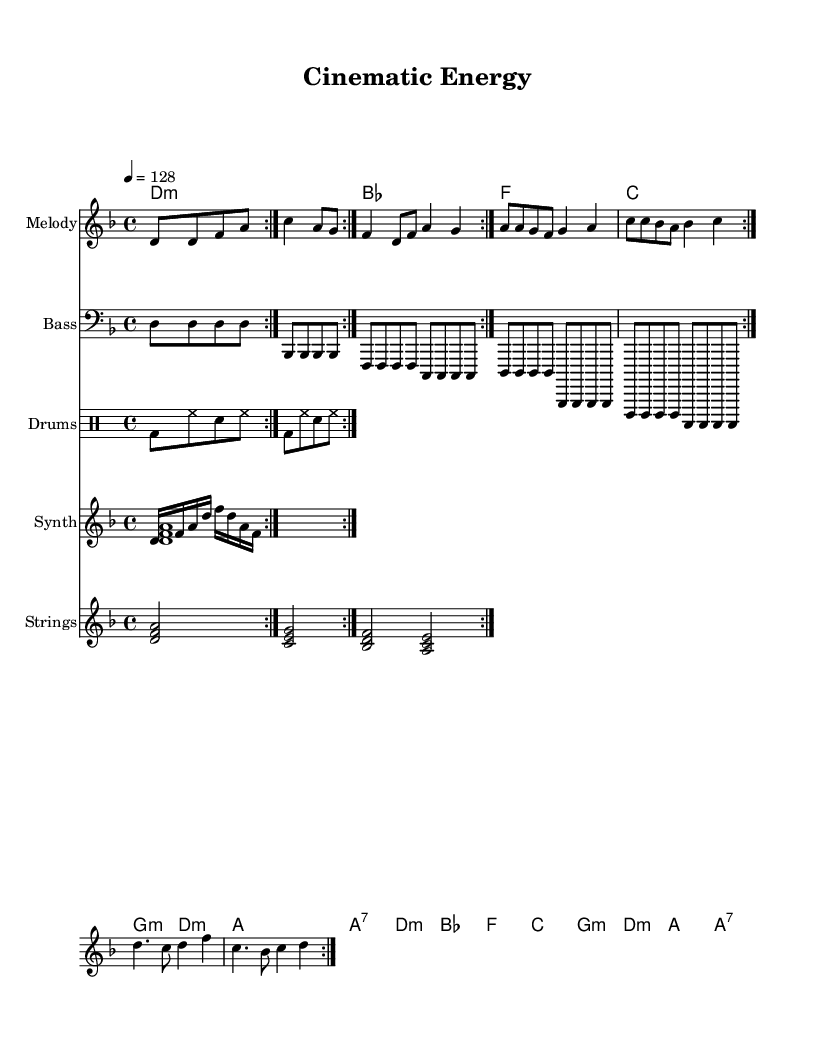What is the key signature of this music? The key signature is indicated at the beginning of the sheet music. Looking at the clef, we can see that it has one flat, positioning it in the key of D minor.
Answer: D minor What is the time signature of this music? The time signature is displayed at the beginning of the score. Here, it is shown as 4/4, indicating four beats per measure.
Answer: 4/4 What is the tempo marking for the piece? The tempo is specified at the beginning with the metronome marking "4 = 128," which indicates that there are 128 beats in a minute, associated with quarter notes.
Answer: 128 How many repetitions are indicated for each section in the melody? In the melody section, the notation "volta 2" indicates that each phrase is to be repeated twice. Thus, each section has two repetitions.
Answer: 2 Which instrument plays the bassline in this score? The bassline is notated on a staff labeled "Bass," which indicates that a bass instrument plays this part specifically.
Answer: Bass What type of drum pattern is utilized in this music? The drum pattern is displayed in a dedicated drum staff, using a standard rock beat format of bass drum (bd), hi-hat (hh), and snare drum (sn), typically common in energetic K-pop tracks.
Answer: Rock beat What is unique about the synthesizer parts in this track? The synthesizer parts include both an arpeggiated figure and a sustained pad, which are characteristic of K-pop music, providing both harmonic texture and rhythmic movement.
Answer: Arpeggiated and sustained pad 